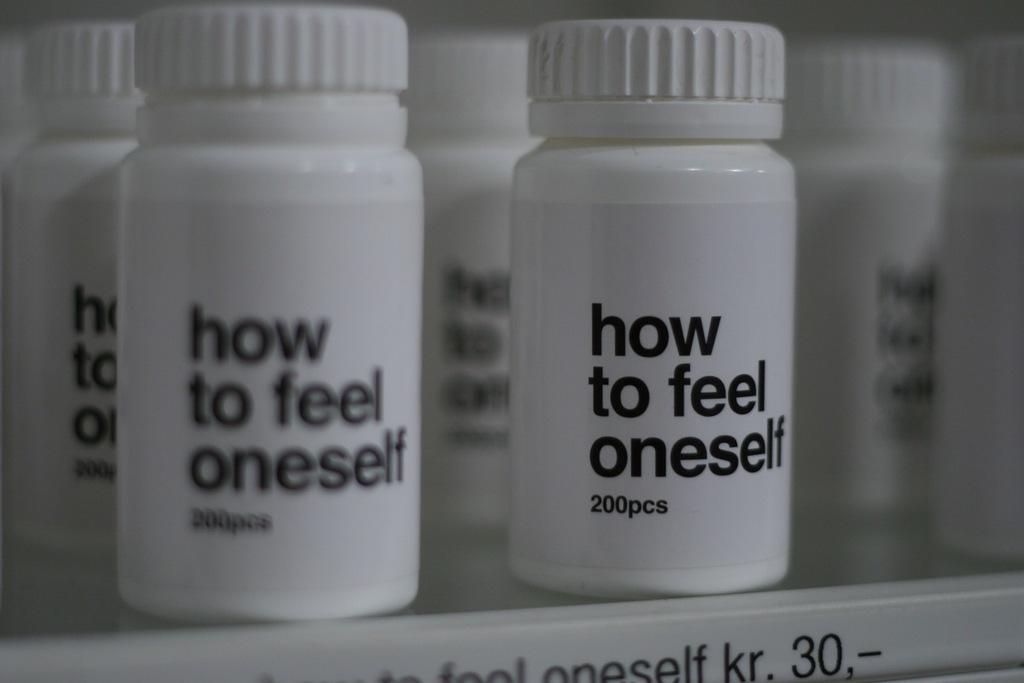What does the text say on the bottles?
Provide a short and direct response. How to feel oneself. 